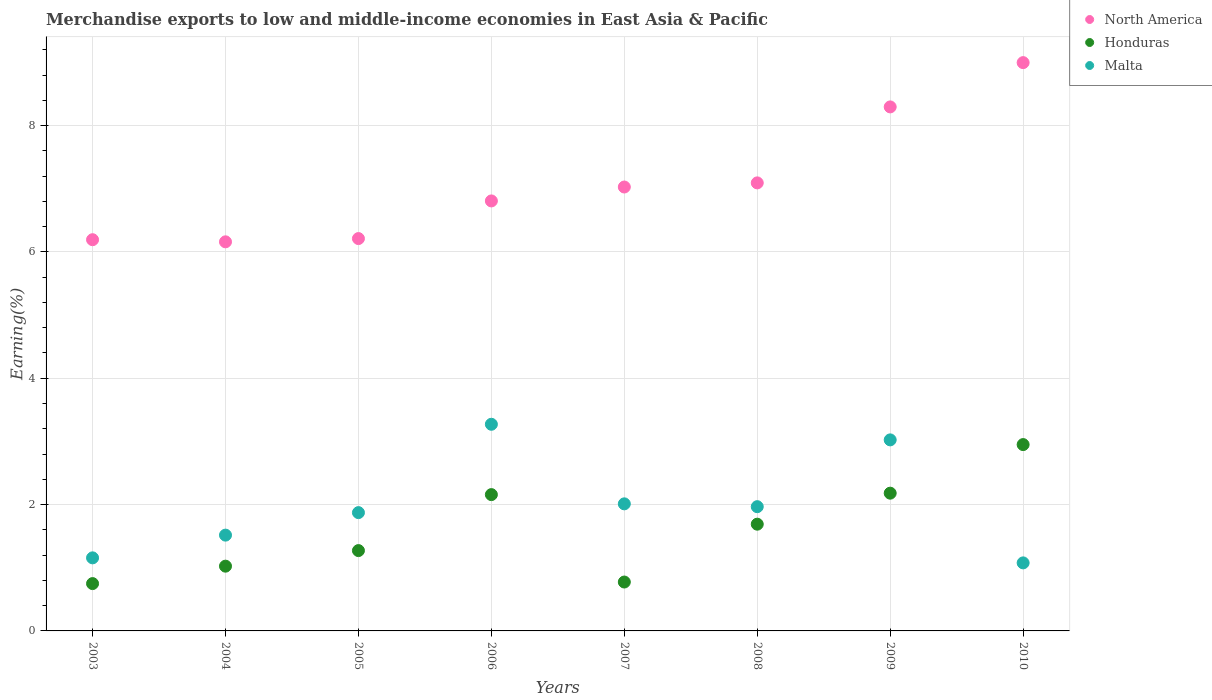How many different coloured dotlines are there?
Make the answer very short. 3. What is the percentage of amount earned from merchandise exports in North America in 2009?
Give a very brief answer. 8.3. Across all years, what is the maximum percentage of amount earned from merchandise exports in Malta?
Make the answer very short. 3.27. Across all years, what is the minimum percentage of amount earned from merchandise exports in Malta?
Give a very brief answer. 1.08. What is the total percentage of amount earned from merchandise exports in Malta in the graph?
Provide a short and direct response. 15.9. What is the difference between the percentage of amount earned from merchandise exports in Honduras in 2004 and that in 2007?
Make the answer very short. 0.25. What is the difference between the percentage of amount earned from merchandise exports in Malta in 2003 and the percentage of amount earned from merchandise exports in North America in 2009?
Ensure brevity in your answer.  -7.14. What is the average percentage of amount earned from merchandise exports in Honduras per year?
Your answer should be compact. 1.6. In the year 2010, what is the difference between the percentage of amount earned from merchandise exports in Malta and percentage of amount earned from merchandise exports in North America?
Your response must be concise. -7.92. In how many years, is the percentage of amount earned from merchandise exports in Malta greater than 8.8 %?
Give a very brief answer. 0. What is the ratio of the percentage of amount earned from merchandise exports in North America in 2005 to that in 2010?
Offer a very short reply. 0.69. Is the percentage of amount earned from merchandise exports in Honduras in 2003 less than that in 2007?
Make the answer very short. Yes. Is the difference between the percentage of amount earned from merchandise exports in Malta in 2004 and 2009 greater than the difference between the percentage of amount earned from merchandise exports in North America in 2004 and 2009?
Offer a terse response. Yes. What is the difference between the highest and the second highest percentage of amount earned from merchandise exports in Malta?
Provide a succinct answer. 0.25. What is the difference between the highest and the lowest percentage of amount earned from merchandise exports in North America?
Make the answer very short. 2.84. In how many years, is the percentage of amount earned from merchandise exports in Malta greater than the average percentage of amount earned from merchandise exports in Malta taken over all years?
Your answer should be very brief. 3. Is it the case that in every year, the sum of the percentage of amount earned from merchandise exports in North America and percentage of amount earned from merchandise exports in Malta  is greater than the percentage of amount earned from merchandise exports in Honduras?
Your answer should be compact. Yes. Does the percentage of amount earned from merchandise exports in Honduras monotonically increase over the years?
Your answer should be compact. No. Is the percentage of amount earned from merchandise exports in North America strictly less than the percentage of amount earned from merchandise exports in Malta over the years?
Provide a short and direct response. No. How many years are there in the graph?
Keep it short and to the point. 8. What is the difference between two consecutive major ticks on the Y-axis?
Provide a short and direct response. 2. Are the values on the major ticks of Y-axis written in scientific E-notation?
Offer a very short reply. No. Where does the legend appear in the graph?
Provide a succinct answer. Top right. What is the title of the graph?
Your response must be concise. Merchandise exports to low and middle-income economies in East Asia & Pacific. Does "Cyprus" appear as one of the legend labels in the graph?
Give a very brief answer. No. What is the label or title of the X-axis?
Offer a terse response. Years. What is the label or title of the Y-axis?
Your answer should be very brief. Earning(%). What is the Earning(%) of North America in 2003?
Make the answer very short. 6.19. What is the Earning(%) of Honduras in 2003?
Keep it short and to the point. 0.75. What is the Earning(%) of Malta in 2003?
Your answer should be compact. 1.16. What is the Earning(%) in North America in 2004?
Provide a succinct answer. 6.16. What is the Earning(%) of Honduras in 2004?
Give a very brief answer. 1.03. What is the Earning(%) of Malta in 2004?
Your answer should be compact. 1.52. What is the Earning(%) in North America in 2005?
Offer a very short reply. 6.21. What is the Earning(%) in Honduras in 2005?
Provide a short and direct response. 1.27. What is the Earning(%) in Malta in 2005?
Your answer should be very brief. 1.87. What is the Earning(%) in North America in 2006?
Your answer should be compact. 6.81. What is the Earning(%) of Honduras in 2006?
Your answer should be very brief. 2.16. What is the Earning(%) of Malta in 2006?
Keep it short and to the point. 3.27. What is the Earning(%) in North America in 2007?
Give a very brief answer. 7.03. What is the Earning(%) in Honduras in 2007?
Offer a very short reply. 0.77. What is the Earning(%) of Malta in 2007?
Your answer should be very brief. 2.01. What is the Earning(%) in North America in 2008?
Provide a succinct answer. 7.09. What is the Earning(%) of Honduras in 2008?
Ensure brevity in your answer.  1.69. What is the Earning(%) in Malta in 2008?
Offer a terse response. 1.97. What is the Earning(%) of North America in 2009?
Offer a terse response. 8.3. What is the Earning(%) of Honduras in 2009?
Provide a succinct answer. 2.18. What is the Earning(%) of Malta in 2009?
Your answer should be compact. 3.02. What is the Earning(%) in North America in 2010?
Provide a succinct answer. 9. What is the Earning(%) of Honduras in 2010?
Ensure brevity in your answer.  2.95. What is the Earning(%) of Malta in 2010?
Offer a terse response. 1.08. Across all years, what is the maximum Earning(%) of North America?
Give a very brief answer. 9. Across all years, what is the maximum Earning(%) in Honduras?
Your response must be concise. 2.95. Across all years, what is the maximum Earning(%) of Malta?
Your answer should be very brief. 3.27. Across all years, what is the minimum Earning(%) in North America?
Offer a terse response. 6.16. Across all years, what is the minimum Earning(%) in Honduras?
Offer a very short reply. 0.75. Across all years, what is the minimum Earning(%) in Malta?
Provide a short and direct response. 1.08. What is the total Earning(%) in North America in the graph?
Provide a succinct answer. 56.78. What is the total Earning(%) in Honduras in the graph?
Your answer should be compact. 12.8. What is the total Earning(%) in Malta in the graph?
Offer a terse response. 15.9. What is the difference between the Earning(%) in North America in 2003 and that in 2004?
Your answer should be very brief. 0.03. What is the difference between the Earning(%) of Honduras in 2003 and that in 2004?
Ensure brevity in your answer.  -0.28. What is the difference between the Earning(%) of Malta in 2003 and that in 2004?
Your response must be concise. -0.36. What is the difference between the Earning(%) of North America in 2003 and that in 2005?
Provide a succinct answer. -0.02. What is the difference between the Earning(%) in Honduras in 2003 and that in 2005?
Provide a succinct answer. -0.52. What is the difference between the Earning(%) of Malta in 2003 and that in 2005?
Provide a succinct answer. -0.72. What is the difference between the Earning(%) in North America in 2003 and that in 2006?
Provide a succinct answer. -0.61. What is the difference between the Earning(%) of Honduras in 2003 and that in 2006?
Give a very brief answer. -1.41. What is the difference between the Earning(%) in Malta in 2003 and that in 2006?
Give a very brief answer. -2.11. What is the difference between the Earning(%) of North America in 2003 and that in 2007?
Your response must be concise. -0.83. What is the difference between the Earning(%) of Honduras in 2003 and that in 2007?
Ensure brevity in your answer.  -0.02. What is the difference between the Earning(%) of Malta in 2003 and that in 2007?
Ensure brevity in your answer.  -0.85. What is the difference between the Earning(%) of North America in 2003 and that in 2008?
Give a very brief answer. -0.9. What is the difference between the Earning(%) of Honduras in 2003 and that in 2008?
Offer a very short reply. -0.94. What is the difference between the Earning(%) of Malta in 2003 and that in 2008?
Your answer should be very brief. -0.81. What is the difference between the Earning(%) in North America in 2003 and that in 2009?
Give a very brief answer. -2.1. What is the difference between the Earning(%) in Honduras in 2003 and that in 2009?
Keep it short and to the point. -1.43. What is the difference between the Earning(%) of Malta in 2003 and that in 2009?
Keep it short and to the point. -1.87. What is the difference between the Earning(%) of North America in 2003 and that in 2010?
Provide a succinct answer. -2.8. What is the difference between the Earning(%) in Honduras in 2003 and that in 2010?
Offer a terse response. -2.2. What is the difference between the Earning(%) in Malta in 2003 and that in 2010?
Your answer should be compact. 0.08. What is the difference between the Earning(%) of North America in 2004 and that in 2005?
Keep it short and to the point. -0.05. What is the difference between the Earning(%) in Honduras in 2004 and that in 2005?
Provide a succinct answer. -0.25. What is the difference between the Earning(%) in Malta in 2004 and that in 2005?
Your answer should be compact. -0.36. What is the difference between the Earning(%) in North America in 2004 and that in 2006?
Provide a succinct answer. -0.65. What is the difference between the Earning(%) in Honduras in 2004 and that in 2006?
Provide a short and direct response. -1.13. What is the difference between the Earning(%) in Malta in 2004 and that in 2006?
Make the answer very short. -1.75. What is the difference between the Earning(%) of North America in 2004 and that in 2007?
Ensure brevity in your answer.  -0.87. What is the difference between the Earning(%) in Honduras in 2004 and that in 2007?
Provide a short and direct response. 0.25. What is the difference between the Earning(%) of Malta in 2004 and that in 2007?
Keep it short and to the point. -0.5. What is the difference between the Earning(%) in North America in 2004 and that in 2008?
Keep it short and to the point. -0.93. What is the difference between the Earning(%) in Honduras in 2004 and that in 2008?
Your response must be concise. -0.66. What is the difference between the Earning(%) of Malta in 2004 and that in 2008?
Ensure brevity in your answer.  -0.45. What is the difference between the Earning(%) in North America in 2004 and that in 2009?
Offer a terse response. -2.14. What is the difference between the Earning(%) in Honduras in 2004 and that in 2009?
Ensure brevity in your answer.  -1.16. What is the difference between the Earning(%) of Malta in 2004 and that in 2009?
Keep it short and to the point. -1.51. What is the difference between the Earning(%) in North America in 2004 and that in 2010?
Give a very brief answer. -2.84. What is the difference between the Earning(%) of Honduras in 2004 and that in 2010?
Provide a short and direct response. -1.92. What is the difference between the Earning(%) of Malta in 2004 and that in 2010?
Provide a succinct answer. 0.44. What is the difference between the Earning(%) in North America in 2005 and that in 2006?
Ensure brevity in your answer.  -0.6. What is the difference between the Earning(%) of Honduras in 2005 and that in 2006?
Offer a terse response. -0.89. What is the difference between the Earning(%) of Malta in 2005 and that in 2006?
Give a very brief answer. -1.4. What is the difference between the Earning(%) in North America in 2005 and that in 2007?
Offer a terse response. -0.82. What is the difference between the Earning(%) in Honduras in 2005 and that in 2007?
Your answer should be very brief. 0.5. What is the difference between the Earning(%) in Malta in 2005 and that in 2007?
Provide a succinct answer. -0.14. What is the difference between the Earning(%) in North America in 2005 and that in 2008?
Make the answer very short. -0.88. What is the difference between the Earning(%) in Honduras in 2005 and that in 2008?
Ensure brevity in your answer.  -0.42. What is the difference between the Earning(%) of Malta in 2005 and that in 2008?
Provide a short and direct response. -0.09. What is the difference between the Earning(%) of North America in 2005 and that in 2009?
Your answer should be compact. -2.08. What is the difference between the Earning(%) in Honduras in 2005 and that in 2009?
Keep it short and to the point. -0.91. What is the difference between the Earning(%) of Malta in 2005 and that in 2009?
Provide a short and direct response. -1.15. What is the difference between the Earning(%) of North America in 2005 and that in 2010?
Give a very brief answer. -2.79. What is the difference between the Earning(%) in Honduras in 2005 and that in 2010?
Provide a succinct answer. -1.68. What is the difference between the Earning(%) of Malta in 2005 and that in 2010?
Provide a short and direct response. 0.8. What is the difference between the Earning(%) of North America in 2006 and that in 2007?
Provide a succinct answer. -0.22. What is the difference between the Earning(%) in Honduras in 2006 and that in 2007?
Give a very brief answer. 1.38. What is the difference between the Earning(%) in Malta in 2006 and that in 2007?
Provide a short and direct response. 1.26. What is the difference between the Earning(%) of North America in 2006 and that in 2008?
Provide a succinct answer. -0.29. What is the difference between the Earning(%) in Honduras in 2006 and that in 2008?
Offer a terse response. 0.47. What is the difference between the Earning(%) of Malta in 2006 and that in 2008?
Offer a very short reply. 1.3. What is the difference between the Earning(%) of North America in 2006 and that in 2009?
Your answer should be very brief. -1.49. What is the difference between the Earning(%) in Honduras in 2006 and that in 2009?
Your answer should be compact. -0.02. What is the difference between the Earning(%) in Malta in 2006 and that in 2009?
Provide a short and direct response. 0.25. What is the difference between the Earning(%) of North America in 2006 and that in 2010?
Give a very brief answer. -2.19. What is the difference between the Earning(%) in Honduras in 2006 and that in 2010?
Your answer should be compact. -0.79. What is the difference between the Earning(%) of Malta in 2006 and that in 2010?
Provide a succinct answer. 2.19. What is the difference between the Earning(%) of North America in 2007 and that in 2008?
Ensure brevity in your answer.  -0.07. What is the difference between the Earning(%) of Honduras in 2007 and that in 2008?
Provide a short and direct response. -0.92. What is the difference between the Earning(%) in Malta in 2007 and that in 2008?
Provide a succinct answer. 0.04. What is the difference between the Earning(%) in North America in 2007 and that in 2009?
Provide a succinct answer. -1.27. What is the difference between the Earning(%) in Honduras in 2007 and that in 2009?
Offer a very short reply. -1.41. What is the difference between the Earning(%) of Malta in 2007 and that in 2009?
Ensure brevity in your answer.  -1.01. What is the difference between the Earning(%) in North America in 2007 and that in 2010?
Keep it short and to the point. -1.97. What is the difference between the Earning(%) in Honduras in 2007 and that in 2010?
Your answer should be compact. -2.18. What is the difference between the Earning(%) of Malta in 2007 and that in 2010?
Keep it short and to the point. 0.93. What is the difference between the Earning(%) in North America in 2008 and that in 2009?
Provide a short and direct response. -1.2. What is the difference between the Earning(%) in Honduras in 2008 and that in 2009?
Your answer should be very brief. -0.49. What is the difference between the Earning(%) in Malta in 2008 and that in 2009?
Make the answer very short. -1.06. What is the difference between the Earning(%) of North America in 2008 and that in 2010?
Your answer should be compact. -1.9. What is the difference between the Earning(%) in Honduras in 2008 and that in 2010?
Make the answer very short. -1.26. What is the difference between the Earning(%) in Malta in 2008 and that in 2010?
Offer a terse response. 0.89. What is the difference between the Earning(%) in North America in 2009 and that in 2010?
Your response must be concise. -0.7. What is the difference between the Earning(%) in Honduras in 2009 and that in 2010?
Give a very brief answer. -0.77. What is the difference between the Earning(%) in Malta in 2009 and that in 2010?
Provide a succinct answer. 1.95. What is the difference between the Earning(%) in North America in 2003 and the Earning(%) in Honduras in 2004?
Give a very brief answer. 5.17. What is the difference between the Earning(%) in North America in 2003 and the Earning(%) in Malta in 2004?
Provide a short and direct response. 4.68. What is the difference between the Earning(%) of Honduras in 2003 and the Earning(%) of Malta in 2004?
Your response must be concise. -0.77. What is the difference between the Earning(%) in North America in 2003 and the Earning(%) in Honduras in 2005?
Keep it short and to the point. 4.92. What is the difference between the Earning(%) in North America in 2003 and the Earning(%) in Malta in 2005?
Keep it short and to the point. 4.32. What is the difference between the Earning(%) of Honduras in 2003 and the Earning(%) of Malta in 2005?
Ensure brevity in your answer.  -1.12. What is the difference between the Earning(%) in North America in 2003 and the Earning(%) in Honduras in 2006?
Make the answer very short. 4.04. What is the difference between the Earning(%) in North America in 2003 and the Earning(%) in Malta in 2006?
Your answer should be very brief. 2.92. What is the difference between the Earning(%) in Honduras in 2003 and the Earning(%) in Malta in 2006?
Your answer should be compact. -2.52. What is the difference between the Earning(%) in North America in 2003 and the Earning(%) in Honduras in 2007?
Offer a very short reply. 5.42. What is the difference between the Earning(%) in North America in 2003 and the Earning(%) in Malta in 2007?
Provide a short and direct response. 4.18. What is the difference between the Earning(%) of Honduras in 2003 and the Earning(%) of Malta in 2007?
Provide a short and direct response. -1.26. What is the difference between the Earning(%) in North America in 2003 and the Earning(%) in Honduras in 2008?
Provide a succinct answer. 4.5. What is the difference between the Earning(%) in North America in 2003 and the Earning(%) in Malta in 2008?
Make the answer very short. 4.23. What is the difference between the Earning(%) in Honduras in 2003 and the Earning(%) in Malta in 2008?
Keep it short and to the point. -1.22. What is the difference between the Earning(%) in North America in 2003 and the Earning(%) in Honduras in 2009?
Offer a terse response. 4.01. What is the difference between the Earning(%) in North America in 2003 and the Earning(%) in Malta in 2009?
Keep it short and to the point. 3.17. What is the difference between the Earning(%) of Honduras in 2003 and the Earning(%) of Malta in 2009?
Give a very brief answer. -2.28. What is the difference between the Earning(%) of North America in 2003 and the Earning(%) of Honduras in 2010?
Make the answer very short. 3.24. What is the difference between the Earning(%) in North America in 2003 and the Earning(%) in Malta in 2010?
Offer a terse response. 5.12. What is the difference between the Earning(%) of Honduras in 2003 and the Earning(%) of Malta in 2010?
Provide a succinct answer. -0.33. What is the difference between the Earning(%) in North America in 2004 and the Earning(%) in Honduras in 2005?
Keep it short and to the point. 4.89. What is the difference between the Earning(%) of North America in 2004 and the Earning(%) of Malta in 2005?
Provide a short and direct response. 4.29. What is the difference between the Earning(%) of Honduras in 2004 and the Earning(%) of Malta in 2005?
Your response must be concise. -0.85. What is the difference between the Earning(%) of North America in 2004 and the Earning(%) of Honduras in 2006?
Your answer should be compact. 4. What is the difference between the Earning(%) in North America in 2004 and the Earning(%) in Malta in 2006?
Give a very brief answer. 2.89. What is the difference between the Earning(%) of Honduras in 2004 and the Earning(%) of Malta in 2006?
Keep it short and to the point. -2.25. What is the difference between the Earning(%) of North America in 2004 and the Earning(%) of Honduras in 2007?
Give a very brief answer. 5.39. What is the difference between the Earning(%) in North America in 2004 and the Earning(%) in Malta in 2007?
Ensure brevity in your answer.  4.15. What is the difference between the Earning(%) of Honduras in 2004 and the Earning(%) of Malta in 2007?
Provide a succinct answer. -0.99. What is the difference between the Earning(%) in North America in 2004 and the Earning(%) in Honduras in 2008?
Provide a succinct answer. 4.47. What is the difference between the Earning(%) in North America in 2004 and the Earning(%) in Malta in 2008?
Give a very brief answer. 4.19. What is the difference between the Earning(%) in Honduras in 2004 and the Earning(%) in Malta in 2008?
Make the answer very short. -0.94. What is the difference between the Earning(%) of North America in 2004 and the Earning(%) of Honduras in 2009?
Offer a very short reply. 3.98. What is the difference between the Earning(%) in North America in 2004 and the Earning(%) in Malta in 2009?
Make the answer very short. 3.14. What is the difference between the Earning(%) in Honduras in 2004 and the Earning(%) in Malta in 2009?
Your answer should be compact. -2. What is the difference between the Earning(%) in North America in 2004 and the Earning(%) in Honduras in 2010?
Keep it short and to the point. 3.21. What is the difference between the Earning(%) in North America in 2004 and the Earning(%) in Malta in 2010?
Ensure brevity in your answer.  5.08. What is the difference between the Earning(%) in Honduras in 2004 and the Earning(%) in Malta in 2010?
Provide a short and direct response. -0.05. What is the difference between the Earning(%) of North America in 2005 and the Earning(%) of Honduras in 2006?
Keep it short and to the point. 4.05. What is the difference between the Earning(%) of North America in 2005 and the Earning(%) of Malta in 2006?
Your answer should be compact. 2.94. What is the difference between the Earning(%) of Honduras in 2005 and the Earning(%) of Malta in 2006?
Your response must be concise. -2. What is the difference between the Earning(%) in North America in 2005 and the Earning(%) in Honduras in 2007?
Your answer should be very brief. 5.44. What is the difference between the Earning(%) in North America in 2005 and the Earning(%) in Malta in 2007?
Your answer should be compact. 4.2. What is the difference between the Earning(%) in Honduras in 2005 and the Earning(%) in Malta in 2007?
Keep it short and to the point. -0.74. What is the difference between the Earning(%) in North America in 2005 and the Earning(%) in Honduras in 2008?
Your answer should be compact. 4.52. What is the difference between the Earning(%) in North America in 2005 and the Earning(%) in Malta in 2008?
Provide a succinct answer. 4.24. What is the difference between the Earning(%) of Honduras in 2005 and the Earning(%) of Malta in 2008?
Provide a succinct answer. -0.7. What is the difference between the Earning(%) in North America in 2005 and the Earning(%) in Honduras in 2009?
Provide a short and direct response. 4.03. What is the difference between the Earning(%) of North America in 2005 and the Earning(%) of Malta in 2009?
Provide a succinct answer. 3.19. What is the difference between the Earning(%) in Honduras in 2005 and the Earning(%) in Malta in 2009?
Your answer should be compact. -1.75. What is the difference between the Earning(%) of North America in 2005 and the Earning(%) of Honduras in 2010?
Give a very brief answer. 3.26. What is the difference between the Earning(%) in North America in 2005 and the Earning(%) in Malta in 2010?
Your answer should be compact. 5.13. What is the difference between the Earning(%) in Honduras in 2005 and the Earning(%) in Malta in 2010?
Make the answer very short. 0.19. What is the difference between the Earning(%) in North America in 2006 and the Earning(%) in Honduras in 2007?
Ensure brevity in your answer.  6.03. What is the difference between the Earning(%) of North America in 2006 and the Earning(%) of Malta in 2007?
Make the answer very short. 4.8. What is the difference between the Earning(%) in Honduras in 2006 and the Earning(%) in Malta in 2007?
Your response must be concise. 0.15. What is the difference between the Earning(%) of North America in 2006 and the Earning(%) of Honduras in 2008?
Keep it short and to the point. 5.12. What is the difference between the Earning(%) in North America in 2006 and the Earning(%) in Malta in 2008?
Make the answer very short. 4.84. What is the difference between the Earning(%) in Honduras in 2006 and the Earning(%) in Malta in 2008?
Offer a very short reply. 0.19. What is the difference between the Earning(%) of North America in 2006 and the Earning(%) of Honduras in 2009?
Offer a very short reply. 4.63. What is the difference between the Earning(%) in North America in 2006 and the Earning(%) in Malta in 2009?
Give a very brief answer. 3.78. What is the difference between the Earning(%) of Honduras in 2006 and the Earning(%) of Malta in 2009?
Offer a very short reply. -0.87. What is the difference between the Earning(%) of North America in 2006 and the Earning(%) of Honduras in 2010?
Ensure brevity in your answer.  3.86. What is the difference between the Earning(%) of North America in 2006 and the Earning(%) of Malta in 2010?
Your answer should be compact. 5.73. What is the difference between the Earning(%) of Honduras in 2006 and the Earning(%) of Malta in 2010?
Your answer should be very brief. 1.08. What is the difference between the Earning(%) in North America in 2007 and the Earning(%) in Honduras in 2008?
Keep it short and to the point. 5.34. What is the difference between the Earning(%) of North America in 2007 and the Earning(%) of Malta in 2008?
Offer a terse response. 5.06. What is the difference between the Earning(%) in Honduras in 2007 and the Earning(%) in Malta in 2008?
Provide a succinct answer. -1.19. What is the difference between the Earning(%) in North America in 2007 and the Earning(%) in Honduras in 2009?
Give a very brief answer. 4.85. What is the difference between the Earning(%) in North America in 2007 and the Earning(%) in Malta in 2009?
Your response must be concise. 4. What is the difference between the Earning(%) of Honduras in 2007 and the Earning(%) of Malta in 2009?
Keep it short and to the point. -2.25. What is the difference between the Earning(%) in North America in 2007 and the Earning(%) in Honduras in 2010?
Give a very brief answer. 4.08. What is the difference between the Earning(%) in North America in 2007 and the Earning(%) in Malta in 2010?
Provide a short and direct response. 5.95. What is the difference between the Earning(%) in Honduras in 2007 and the Earning(%) in Malta in 2010?
Ensure brevity in your answer.  -0.3. What is the difference between the Earning(%) of North America in 2008 and the Earning(%) of Honduras in 2009?
Your response must be concise. 4.91. What is the difference between the Earning(%) in North America in 2008 and the Earning(%) in Malta in 2009?
Provide a short and direct response. 4.07. What is the difference between the Earning(%) in Honduras in 2008 and the Earning(%) in Malta in 2009?
Ensure brevity in your answer.  -1.33. What is the difference between the Earning(%) of North America in 2008 and the Earning(%) of Honduras in 2010?
Provide a short and direct response. 4.14. What is the difference between the Earning(%) of North America in 2008 and the Earning(%) of Malta in 2010?
Ensure brevity in your answer.  6.02. What is the difference between the Earning(%) in Honduras in 2008 and the Earning(%) in Malta in 2010?
Give a very brief answer. 0.61. What is the difference between the Earning(%) in North America in 2009 and the Earning(%) in Honduras in 2010?
Your response must be concise. 5.35. What is the difference between the Earning(%) of North America in 2009 and the Earning(%) of Malta in 2010?
Ensure brevity in your answer.  7.22. What is the difference between the Earning(%) in Honduras in 2009 and the Earning(%) in Malta in 2010?
Offer a terse response. 1.1. What is the average Earning(%) of North America per year?
Ensure brevity in your answer.  7.1. What is the average Earning(%) in Honduras per year?
Your answer should be very brief. 1.6. What is the average Earning(%) in Malta per year?
Provide a succinct answer. 1.99. In the year 2003, what is the difference between the Earning(%) in North America and Earning(%) in Honduras?
Your answer should be compact. 5.44. In the year 2003, what is the difference between the Earning(%) of North America and Earning(%) of Malta?
Ensure brevity in your answer.  5.04. In the year 2003, what is the difference between the Earning(%) in Honduras and Earning(%) in Malta?
Your answer should be very brief. -0.41. In the year 2004, what is the difference between the Earning(%) in North America and Earning(%) in Honduras?
Your answer should be very brief. 5.13. In the year 2004, what is the difference between the Earning(%) in North America and Earning(%) in Malta?
Your answer should be compact. 4.64. In the year 2004, what is the difference between the Earning(%) in Honduras and Earning(%) in Malta?
Your answer should be compact. -0.49. In the year 2005, what is the difference between the Earning(%) in North America and Earning(%) in Honduras?
Give a very brief answer. 4.94. In the year 2005, what is the difference between the Earning(%) of North America and Earning(%) of Malta?
Your answer should be compact. 4.34. In the year 2005, what is the difference between the Earning(%) of Honduras and Earning(%) of Malta?
Keep it short and to the point. -0.6. In the year 2006, what is the difference between the Earning(%) of North America and Earning(%) of Honduras?
Keep it short and to the point. 4.65. In the year 2006, what is the difference between the Earning(%) in North America and Earning(%) in Malta?
Keep it short and to the point. 3.54. In the year 2006, what is the difference between the Earning(%) in Honduras and Earning(%) in Malta?
Offer a terse response. -1.11. In the year 2007, what is the difference between the Earning(%) of North America and Earning(%) of Honduras?
Offer a terse response. 6.25. In the year 2007, what is the difference between the Earning(%) of North America and Earning(%) of Malta?
Provide a short and direct response. 5.02. In the year 2007, what is the difference between the Earning(%) in Honduras and Earning(%) in Malta?
Your answer should be very brief. -1.24. In the year 2008, what is the difference between the Earning(%) in North America and Earning(%) in Honduras?
Offer a terse response. 5.4. In the year 2008, what is the difference between the Earning(%) of North America and Earning(%) of Malta?
Your answer should be compact. 5.13. In the year 2008, what is the difference between the Earning(%) in Honduras and Earning(%) in Malta?
Give a very brief answer. -0.28. In the year 2009, what is the difference between the Earning(%) of North America and Earning(%) of Honduras?
Provide a succinct answer. 6.12. In the year 2009, what is the difference between the Earning(%) of North America and Earning(%) of Malta?
Your answer should be compact. 5.27. In the year 2009, what is the difference between the Earning(%) in Honduras and Earning(%) in Malta?
Ensure brevity in your answer.  -0.84. In the year 2010, what is the difference between the Earning(%) of North America and Earning(%) of Honduras?
Provide a succinct answer. 6.05. In the year 2010, what is the difference between the Earning(%) in North America and Earning(%) in Malta?
Provide a succinct answer. 7.92. In the year 2010, what is the difference between the Earning(%) of Honduras and Earning(%) of Malta?
Give a very brief answer. 1.87. What is the ratio of the Earning(%) in North America in 2003 to that in 2004?
Your response must be concise. 1.01. What is the ratio of the Earning(%) of Honduras in 2003 to that in 2004?
Give a very brief answer. 0.73. What is the ratio of the Earning(%) of Malta in 2003 to that in 2004?
Keep it short and to the point. 0.76. What is the ratio of the Earning(%) in North America in 2003 to that in 2005?
Your response must be concise. 1. What is the ratio of the Earning(%) in Honduras in 2003 to that in 2005?
Your answer should be compact. 0.59. What is the ratio of the Earning(%) in Malta in 2003 to that in 2005?
Provide a succinct answer. 0.62. What is the ratio of the Earning(%) in North America in 2003 to that in 2006?
Your response must be concise. 0.91. What is the ratio of the Earning(%) in Honduras in 2003 to that in 2006?
Provide a succinct answer. 0.35. What is the ratio of the Earning(%) of Malta in 2003 to that in 2006?
Offer a very short reply. 0.35. What is the ratio of the Earning(%) of North America in 2003 to that in 2007?
Ensure brevity in your answer.  0.88. What is the ratio of the Earning(%) in Honduras in 2003 to that in 2007?
Offer a terse response. 0.97. What is the ratio of the Earning(%) of Malta in 2003 to that in 2007?
Keep it short and to the point. 0.57. What is the ratio of the Earning(%) of North America in 2003 to that in 2008?
Keep it short and to the point. 0.87. What is the ratio of the Earning(%) of Honduras in 2003 to that in 2008?
Make the answer very short. 0.44. What is the ratio of the Earning(%) of Malta in 2003 to that in 2008?
Your answer should be compact. 0.59. What is the ratio of the Earning(%) in North America in 2003 to that in 2009?
Provide a succinct answer. 0.75. What is the ratio of the Earning(%) in Honduras in 2003 to that in 2009?
Ensure brevity in your answer.  0.34. What is the ratio of the Earning(%) in Malta in 2003 to that in 2009?
Ensure brevity in your answer.  0.38. What is the ratio of the Earning(%) in North America in 2003 to that in 2010?
Ensure brevity in your answer.  0.69. What is the ratio of the Earning(%) in Honduras in 2003 to that in 2010?
Ensure brevity in your answer.  0.25. What is the ratio of the Earning(%) of Malta in 2003 to that in 2010?
Make the answer very short. 1.07. What is the ratio of the Earning(%) in North America in 2004 to that in 2005?
Offer a terse response. 0.99. What is the ratio of the Earning(%) in Honduras in 2004 to that in 2005?
Your answer should be very brief. 0.81. What is the ratio of the Earning(%) in Malta in 2004 to that in 2005?
Your answer should be very brief. 0.81. What is the ratio of the Earning(%) in North America in 2004 to that in 2006?
Provide a succinct answer. 0.9. What is the ratio of the Earning(%) of Honduras in 2004 to that in 2006?
Give a very brief answer. 0.47. What is the ratio of the Earning(%) in Malta in 2004 to that in 2006?
Provide a short and direct response. 0.46. What is the ratio of the Earning(%) in North America in 2004 to that in 2007?
Provide a succinct answer. 0.88. What is the ratio of the Earning(%) in Honduras in 2004 to that in 2007?
Your answer should be very brief. 1.32. What is the ratio of the Earning(%) of Malta in 2004 to that in 2007?
Ensure brevity in your answer.  0.75. What is the ratio of the Earning(%) in North America in 2004 to that in 2008?
Keep it short and to the point. 0.87. What is the ratio of the Earning(%) in Honduras in 2004 to that in 2008?
Make the answer very short. 0.61. What is the ratio of the Earning(%) in Malta in 2004 to that in 2008?
Provide a succinct answer. 0.77. What is the ratio of the Earning(%) in North America in 2004 to that in 2009?
Offer a terse response. 0.74. What is the ratio of the Earning(%) of Honduras in 2004 to that in 2009?
Offer a terse response. 0.47. What is the ratio of the Earning(%) in Malta in 2004 to that in 2009?
Your answer should be very brief. 0.5. What is the ratio of the Earning(%) of North America in 2004 to that in 2010?
Offer a very short reply. 0.68. What is the ratio of the Earning(%) of Honduras in 2004 to that in 2010?
Your answer should be very brief. 0.35. What is the ratio of the Earning(%) of Malta in 2004 to that in 2010?
Offer a very short reply. 1.41. What is the ratio of the Earning(%) in North America in 2005 to that in 2006?
Ensure brevity in your answer.  0.91. What is the ratio of the Earning(%) in Honduras in 2005 to that in 2006?
Make the answer very short. 0.59. What is the ratio of the Earning(%) in Malta in 2005 to that in 2006?
Give a very brief answer. 0.57. What is the ratio of the Earning(%) in North America in 2005 to that in 2007?
Provide a short and direct response. 0.88. What is the ratio of the Earning(%) of Honduras in 2005 to that in 2007?
Your answer should be compact. 1.64. What is the ratio of the Earning(%) in North America in 2005 to that in 2008?
Make the answer very short. 0.88. What is the ratio of the Earning(%) of Honduras in 2005 to that in 2008?
Your response must be concise. 0.75. What is the ratio of the Earning(%) of Malta in 2005 to that in 2008?
Your answer should be very brief. 0.95. What is the ratio of the Earning(%) of North America in 2005 to that in 2009?
Your response must be concise. 0.75. What is the ratio of the Earning(%) of Honduras in 2005 to that in 2009?
Offer a terse response. 0.58. What is the ratio of the Earning(%) of Malta in 2005 to that in 2009?
Offer a very short reply. 0.62. What is the ratio of the Earning(%) of North America in 2005 to that in 2010?
Offer a terse response. 0.69. What is the ratio of the Earning(%) of Honduras in 2005 to that in 2010?
Give a very brief answer. 0.43. What is the ratio of the Earning(%) of Malta in 2005 to that in 2010?
Your response must be concise. 1.74. What is the ratio of the Earning(%) of North America in 2006 to that in 2007?
Keep it short and to the point. 0.97. What is the ratio of the Earning(%) in Honduras in 2006 to that in 2007?
Offer a very short reply. 2.79. What is the ratio of the Earning(%) in Malta in 2006 to that in 2007?
Ensure brevity in your answer.  1.63. What is the ratio of the Earning(%) in North America in 2006 to that in 2008?
Give a very brief answer. 0.96. What is the ratio of the Earning(%) of Honduras in 2006 to that in 2008?
Provide a succinct answer. 1.28. What is the ratio of the Earning(%) in Malta in 2006 to that in 2008?
Provide a short and direct response. 1.66. What is the ratio of the Earning(%) of North America in 2006 to that in 2009?
Your answer should be compact. 0.82. What is the ratio of the Earning(%) in Malta in 2006 to that in 2009?
Your answer should be compact. 1.08. What is the ratio of the Earning(%) of North America in 2006 to that in 2010?
Keep it short and to the point. 0.76. What is the ratio of the Earning(%) in Honduras in 2006 to that in 2010?
Give a very brief answer. 0.73. What is the ratio of the Earning(%) in Malta in 2006 to that in 2010?
Your answer should be very brief. 3.04. What is the ratio of the Earning(%) in North America in 2007 to that in 2008?
Your answer should be very brief. 0.99. What is the ratio of the Earning(%) of Honduras in 2007 to that in 2008?
Offer a terse response. 0.46. What is the ratio of the Earning(%) in Malta in 2007 to that in 2008?
Offer a very short reply. 1.02. What is the ratio of the Earning(%) of North America in 2007 to that in 2009?
Provide a succinct answer. 0.85. What is the ratio of the Earning(%) of Honduras in 2007 to that in 2009?
Offer a terse response. 0.35. What is the ratio of the Earning(%) in Malta in 2007 to that in 2009?
Give a very brief answer. 0.67. What is the ratio of the Earning(%) of North America in 2007 to that in 2010?
Give a very brief answer. 0.78. What is the ratio of the Earning(%) of Honduras in 2007 to that in 2010?
Give a very brief answer. 0.26. What is the ratio of the Earning(%) of Malta in 2007 to that in 2010?
Offer a terse response. 1.87. What is the ratio of the Earning(%) of North America in 2008 to that in 2009?
Provide a succinct answer. 0.85. What is the ratio of the Earning(%) in Honduras in 2008 to that in 2009?
Your response must be concise. 0.77. What is the ratio of the Earning(%) of Malta in 2008 to that in 2009?
Your answer should be very brief. 0.65. What is the ratio of the Earning(%) in North America in 2008 to that in 2010?
Your answer should be compact. 0.79. What is the ratio of the Earning(%) in Honduras in 2008 to that in 2010?
Your response must be concise. 0.57. What is the ratio of the Earning(%) of Malta in 2008 to that in 2010?
Ensure brevity in your answer.  1.83. What is the ratio of the Earning(%) in North America in 2009 to that in 2010?
Give a very brief answer. 0.92. What is the ratio of the Earning(%) of Honduras in 2009 to that in 2010?
Give a very brief answer. 0.74. What is the ratio of the Earning(%) of Malta in 2009 to that in 2010?
Your response must be concise. 2.81. What is the difference between the highest and the second highest Earning(%) of North America?
Your response must be concise. 0.7. What is the difference between the highest and the second highest Earning(%) in Honduras?
Your answer should be very brief. 0.77. What is the difference between the highest and the second highest Earning(%) in Malta?
Offer a very short reply. 0.25. What is the difference between the highest and the lowest Earning(%) in North America?
Your response must be concise. 2.84. What is the difference between the highest and the lowest Earning(%) in Honduras?
Provide a short and direct response. 2.2. What is the difference between the highest and the lowest Earning(%) of Malta?
Your answer should be very brief. 2.19. 